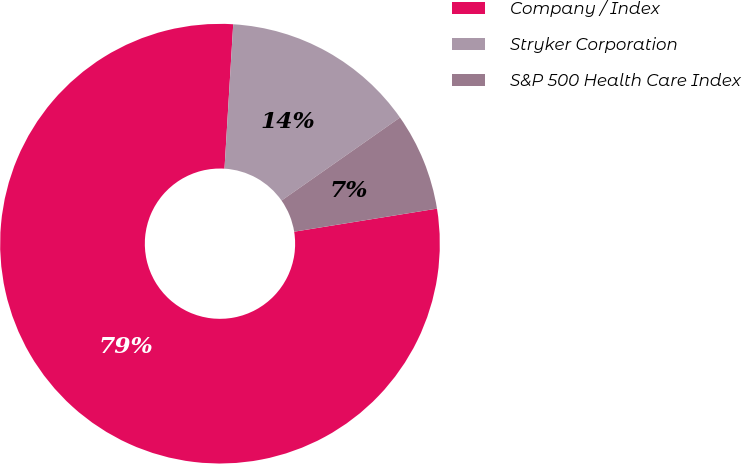Convert chart to OTSL. <chart><loc_0><loc_0><loc_500><loc_500><pie_chart><fcel>Company / Index<fcel>Stryker Corporation<fcel>S&P 500 Health Care Index<nl><fcel>78.5%<fcel>14.31%<fcel>7.18%<nl></chart> 